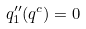<formula> <loc_0><loc_0><loc_500><loc_500>q _ { 1 } ^ { \prime \prime } ( q ^ { c } ) = 0</formula> 